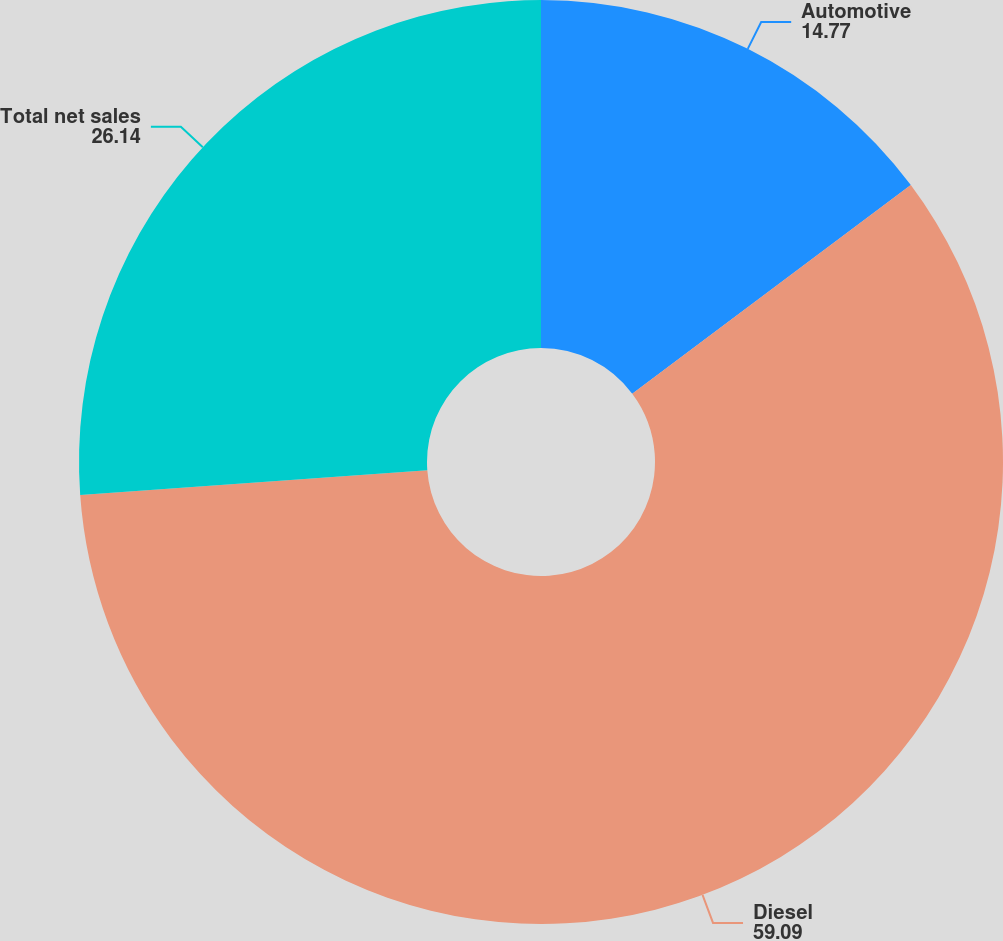Convert chart. <chart><loc_0><loc_0><loc_500><loc_500><pie_chart><fcel>Automotive<fcel>Diesel<fcel>Total net sales<nl><fcel>14.77%<fcel>59.09%<fcel>26.14%<nl></chart> 